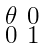<formula> <loc_0><loc_0><loc_500><loc_500>\begin{smallmatrix} \theta & 0 \\ 0 & 1 \end{smallmatrix}</formula> 